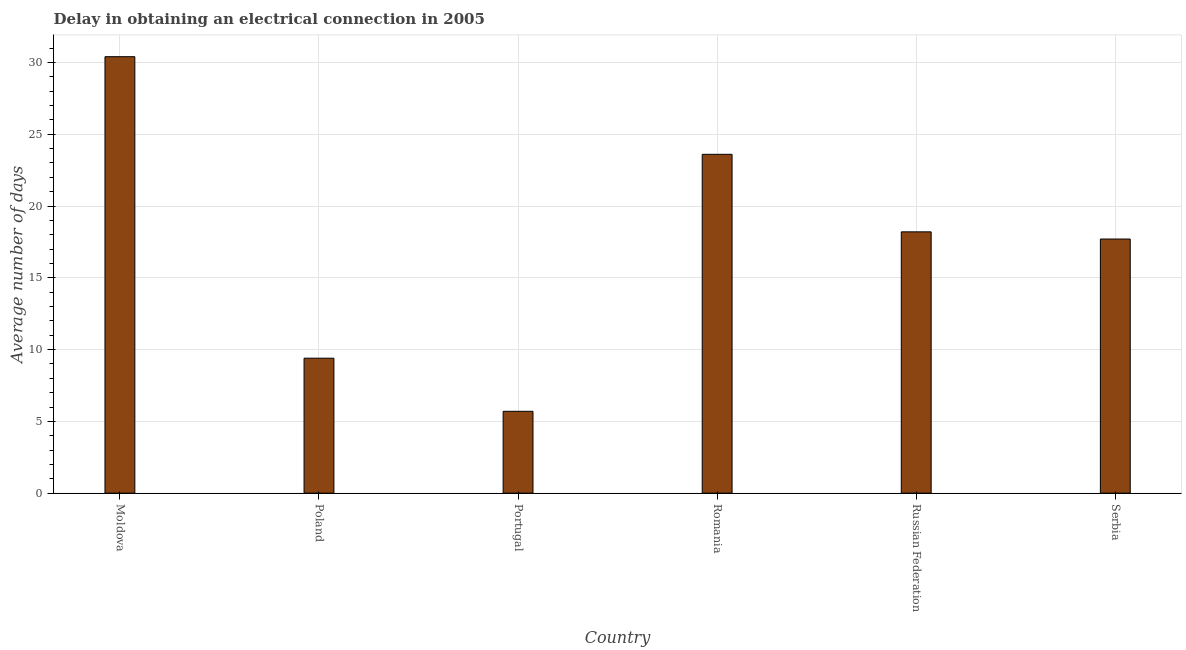Does the graph contain any zero values?
Give a very brief answer. No. Does the graph contain grids?
Offer a terse response. Yes. What is the title of the graph?
Your answer should be very brief. Delay in obtaining an electrical connection in 2005. What is the label or title of the X-axis?
Keep it short and to the point. Country. What is the label or title of the Y-axis?
Keep it short and to the point. Average number of days. What is the dalay in electrical connection in Poland?
Your answer should be compact. 9.4. Across all countries, what is the maximum dalay in electrical connection?
Your answer should be compact. 30.4. In which country was the dalay in electrical connection maximum?
Your answer should be very brief. Moldova. In which country was the dalay in electrical connection minimum?
Make the answer very short. Portugal. What is the sum of the dalay in electrical connection?
Provide a succinct answer. 105. What is the difference between the dalay in electrical connection in Romania and Serbia?
Offer a very short reply. 5.9. What is the median dalay in electrical connection?
Ensure brevity in your answer.  17.95. What is the ratio of the dalay in electrical connection in Poland to that in Romania?
Give a very brief answer. 0.4. Is the difference between the dalay in electrical connection in Poland and Portugal greater than the difference between any two countries?
Ensure brevity in your answer.  No. What is the difference between the highest and the lowest dalay in electrical connection?
Your answer should be compact. 24.7. In how many countries, is the dalay in electrical connection greater than the average dalay in electrical connection taken over all countries?
Give a very brief answer. 4. What is the Average number of days in Moldova?
Provide a succinct answer. 30.4. What is the Average number of days in Portugal?
Give a very brief answer. 5.7. What is the Average number of days in Romania?
Provide a short and direct response. 23.6. What is the Average number of days of Russian Federation?
Give a very brief answer. 18.2. What is the Average number of days in Serbia?
Ensure brevity in your answer.  17.7. What is the difference between the Average number of days in Moldova and Poland?
Your response must be concise. 21. What is the difference between the Average number of days in Moldova and Portugal?
Ensure brevity in your answer.  24.7. What is the difference between the Average number of days in Moldova and Russian Federation?
Offer a terse response. 12.2. What is the difference between the Average number of days in Moldova and Serbia?
Offer a terse response. 12.7. What is the difference between the Average number of days in Poland and Portugal?
Your answer should be compact. 3.7. What is the difference between the Average number of days in Poland and Romania?
Provide a short and direct response. -14.2. What is the difference between the Average number of days in Poland and Russian Federation?
Provide a succinct answer. -8.8. What is the difference between the Average number of days in Poland and Serbia?
Your answer should be compact. -8.3. What is the difference between the Average number of days in Portugal and Romania?
Offer a very short reply. -17.9. What is the difference between the Average number of days in Portugal and Russian Federation?
Give a very brief answer. -12.5. What is the difference between the Average number of days in Portugal and Serbia?
Keep it short and to the point. -12. What is the difference between the Average number of days in Romania and Russian Federation?
Your answer should be compact. 5.4. What is the difference between the Average number of days in Russian Federation and Serbia?
Keep it short and to the point. 0.5. What is the ratio of the Average number of days in Moldova to that in Poland?
Ensure brevity in your answer.  3.23. What is the ratio of the Average number of days in Moldova to that in Portugal?
Your answer should be compact. 5.33. What is the ratio of the Average number of days in Moldova to that in Romania?
Your answer should be compact. 1.29. What is the ratio of the Average number of days in Moldova to that in Russian Federation?
Provide a succinct answer. 1.67. What is the ratio of the Average number of days in Moldova to that in Serbia?
Provide a short and direct response. 1.72. What is the ratio of the Average number of days in Poland to that in Portugal?
Make the answer very short. 1.65. What is the ratio of the Average number of days in Poland to that in Romania?
Offer a very short reply. 0.4. What is the ratio of the Average number of days in Poland to that in Russian Federation?
Offer a very short reply. 0.52. What is the ratio of the Average number of days in Poland to that in Serbia?
Make the answer very short. 0.53. What is the ratio of the Average number of days in Portugal to that in Romania?
Ensure brevity in your answer.  0.24. What is the ratio of the Average number of days in Portugal to that in Russian Federation?
Provide a short and direct response. 0.31. What is the ratio of the Average number of days in Portugal to that in Serbia?
Your answer should be compact. 0.32. What is the ratio of the Average number of days in Romania to that in Russian Federation?
Your answer should be very brief. 1.3. What is the ratio of the Average number of days in Romania to that in Serbia?
Provide a short and direct response. 1.33. What is the ratio of the Average number of days in Russian Federation to that in Serbia?
Make the answer very short. 1.03. 